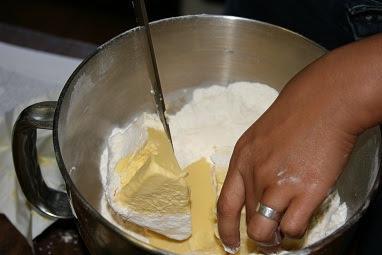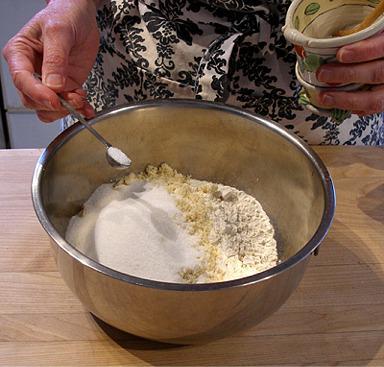The first image is the image on the left, the second image is the image on the right. Analyze the images presented: Is the assertion "The right image shows one hand holding a spoon in a silver-colored bowl as the other hand grips the edge of the bowl." valid? Answer yes or no. No. The first image is the image on the left, the second image is the image on the right. For the images shown, is this caption "In one of the images, the person's hand is pouring an ingredient into the bowl." true? Answer yes or no. Yes. 